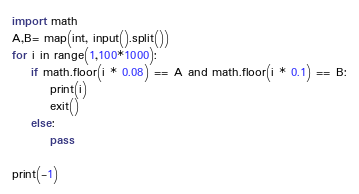Convert code to text. <code><loc_0><loc_0><loc_500><loc_500><_Python_>import math
A,B= map(int, input().split())
for i in range(1,100*1000):
    if math.floor(i * 0.08) == A and math.floor(i * 0.1) == B:
        print(i)
        exit()
    else:
        pass

print(-1)</code> 